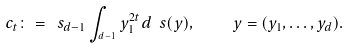<formula> <loc_0><loc_0><loc_500><loc_500>c _ { t } \colon = \ s _ { d - 1 } \int _ { ^ { d - 1 } } y _ { 1 } ^ { 2 t } d \ s ( y ) , \quad y = ( y _ { 1 } , \dots , y _ { d } ) .</formula> 